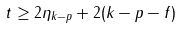Convert formula to latex. <formula><loc_0><loc_0><loc_500><loc_500>t \geq 2 \eta _ { k - p } + 2 ( k - p - f )</formula> 